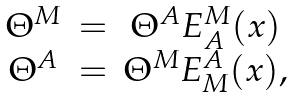<formula> <loc_0><loc_0><loc_500><loc_500>\begin{array} { c c c } \Theta ^ { M } & = & \Theta ^ { A } E ^ { M } _ { A } ( x ) \\ \Theta ^ { A } & = & \Theta ^ { M } E ^ { A } _ { M } ( x ) , \end{array}</formula> 